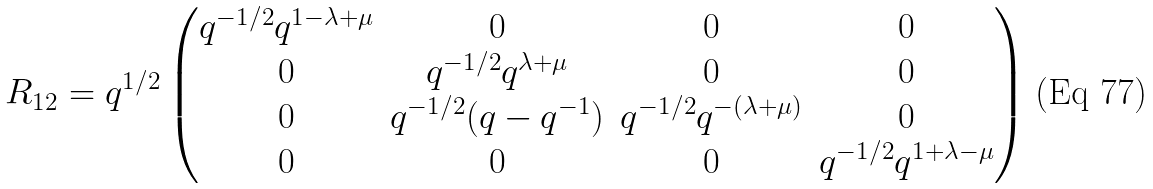<formula> <loc_0><loc_0><loc_500><loc_500>R _ { 1 2 } = q ^ { 1 / 2 } \begin{pmatrix} q ^ { - 1 / 2 } q ^ { 1 - \lambda + \mu } & 0 & 0 & 0 \\ 0 & q ^ { - 1 / 2 } q ^ { \lambda + \mu } & 0 & 0 \\ 0 & q ^ { - 1 / 2 } ( q - q ^ { - 1 } ) & q ^ { - 1 / 2 } q ^ { - ( \lambda + \mu ) } & 0 \\ 0 & 0 & 0 & q ^ { - 1 / 2 } q ^ { 1 + \lambda - \mu } \end{pmatrix}</formula> 